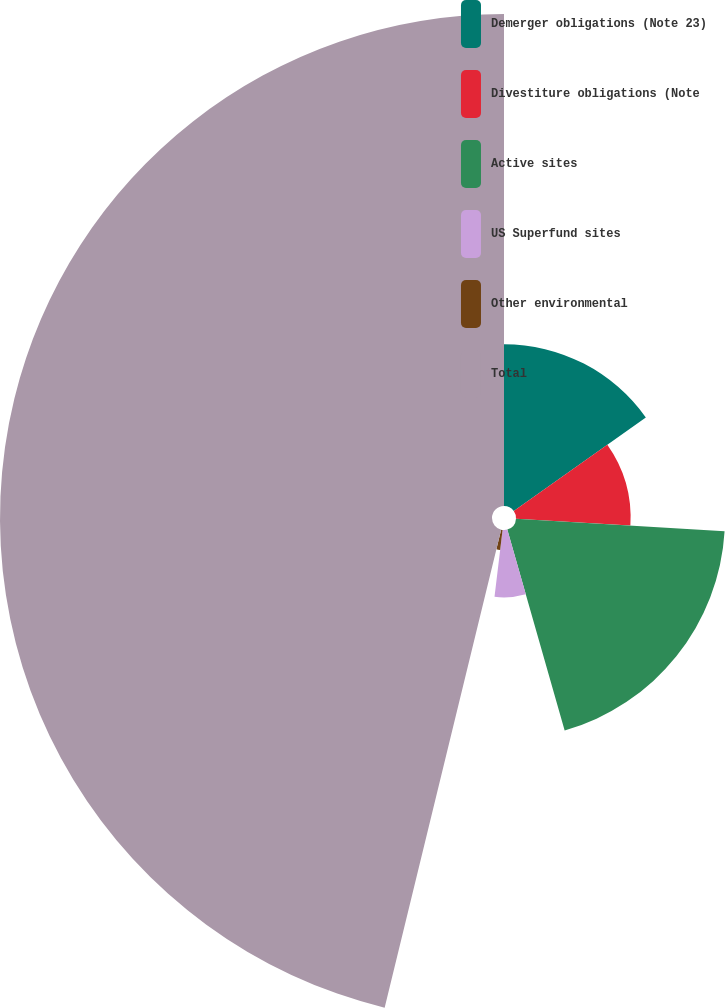Convert chart to OTSL. <chart><loc_0><loc_0><loc_500><loc_500><pie_chart><fcel>Demerger obligations (Note 23)<fcel>Divestiture obligations (Note<fcel>Active sites<fcel>US Superfund sites<fcel>Other environmental<fcel>Total<nl><fcel>15.19%<fcel>10.76%<fcel>19.62%<fcel>6.33%<fcel>1.9%<fcel>46.19%<nl></chart> 